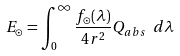<formula> <loc_0><loc_0><loc_500><loc_500>E _ { \odot } = \int _ { 0 } ^ { \infty } \frac { f _ { \odot } ( \lambda ) } { 4 r ^ { 2 } } Q _ { a b s } \ d \lambda</formula> 